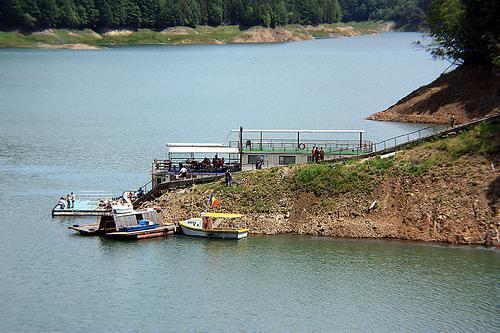How many boats are there?
Give a very brief answer. 2. How many cows are laying?
Give a very brief answer. 0. 